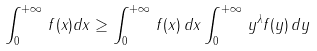<formula> <loc_0><loc_0><loc_500><loc_500>\int _ { 0 } ^ { + \infty } \, f ( x ) d x \geq \int _ { 0 } ^ { + \infty } \, f ( x ) \, d x \int _ { 0 } ^ { + \infty } \, y ^ { \lambda } f ( y ) \, d y</formula> 